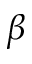<formula> <loc_0><loc_0><loc_500><loc_500>\beta</formula> 